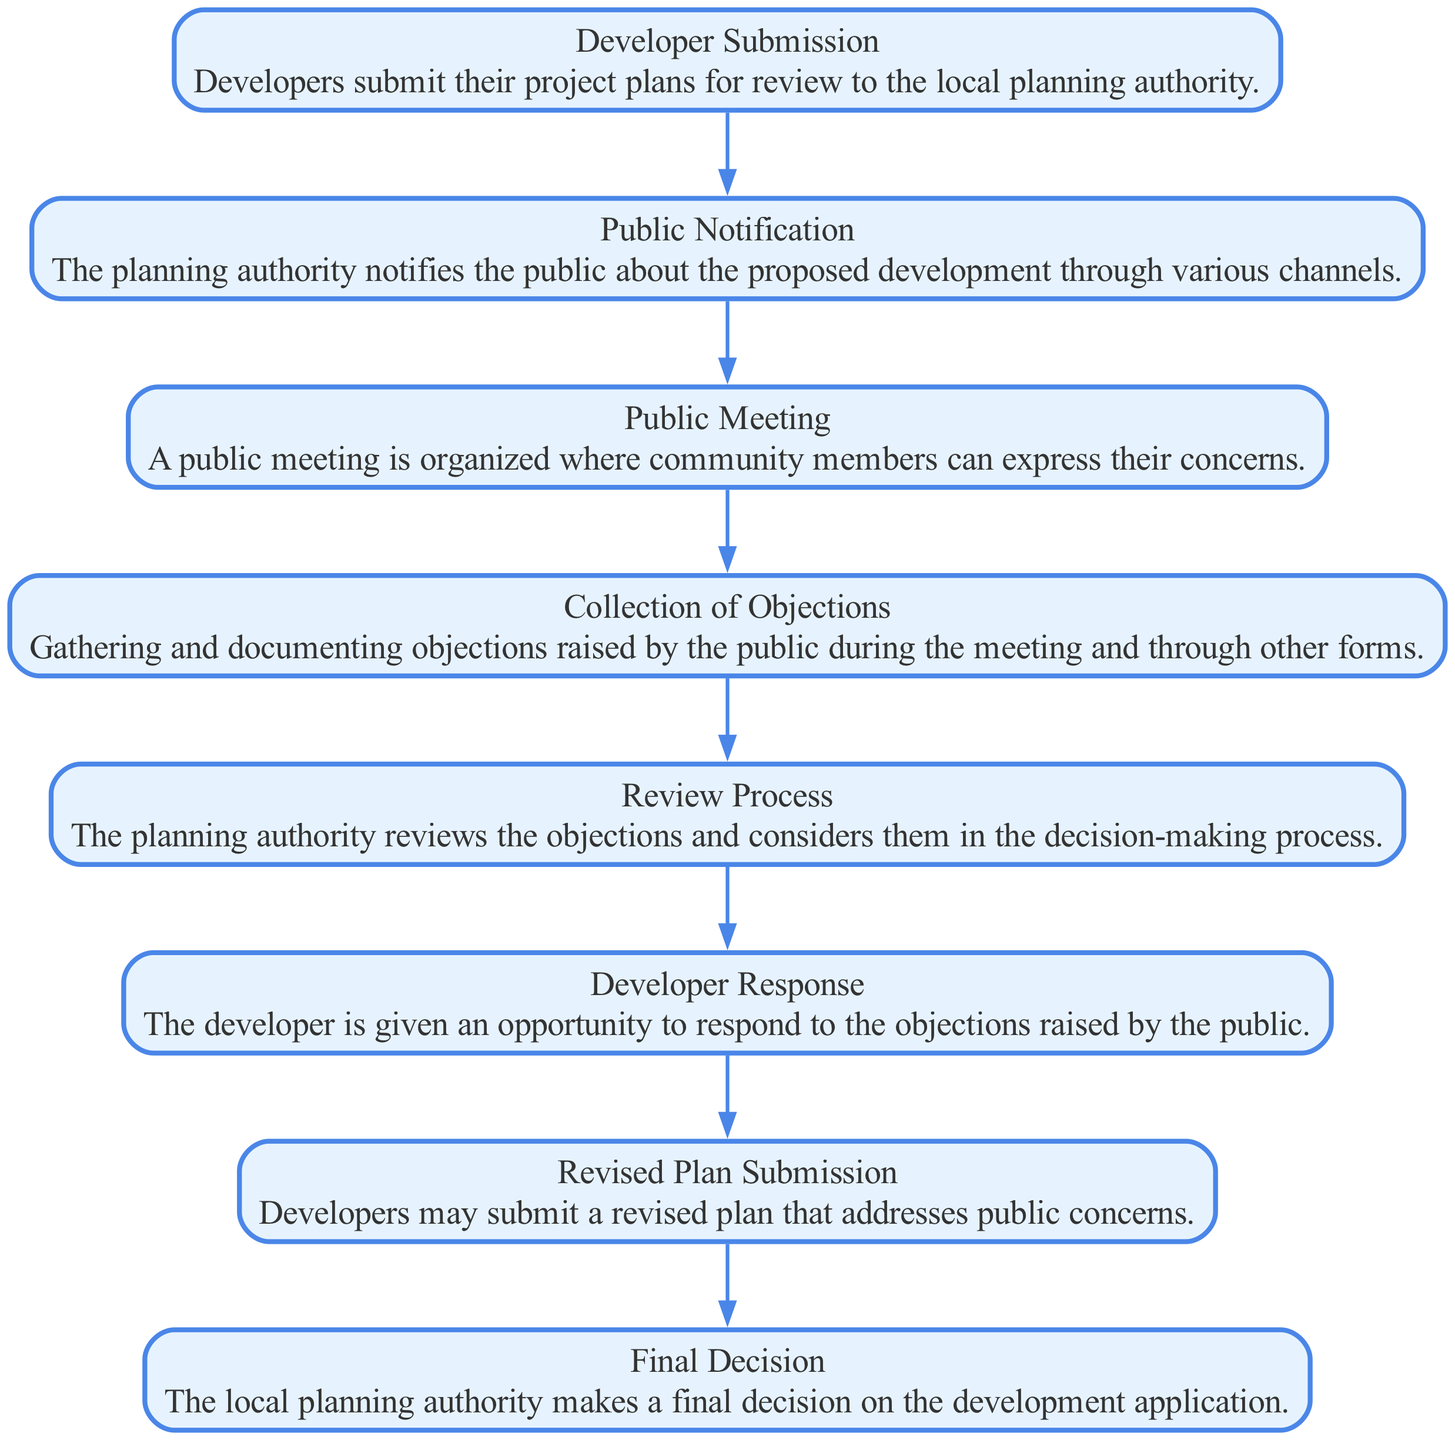What is the first step in the sequence? The first step in the sequence is "Developer Submission", where developers submit their project plans for review to the local planning authority.
Answer: Developer Submission How many total steps are there in the diagram? By counting the listed steps in the sequence, there are eight distinct steps from "Developer Submission" to "Final Decision."
Answer: Eight Which step follows "Public Meeting"? In the sequence, the step that follows "Public Meeting" is "Collection of Objections," where objections raised by the public are gathered and documented.
Answer: Collection of Objections What action does the developer take after the review process? After the Review Process, the action taken by the developer is to provide a "Developer Response" to address the objections raised by the public.
Answer: Developer Response What are the last two steps in the sequence? The last two steps in the sequence are "Revised Plan Submission" where developers may submit a revised plan, followed by "Final Decision" where the local planning authority makes the final decision.
Answer: Revised Plan Submission, Final Decision Which step includes public involvement? The "Public Meeting" step includes public involvement, allowing community members to express their concerns regarding the proposed development.
Answer: Public Meeting What is the purpose of the "Review Process"? The purpose of the "Review Process" is for the planning authority to review the objections raised and consider them in the decision-making process for the development.
Answer: Review Process Which step is directly after "Collection of Objections"? The step that comes directly after "Collection of Objections" is "Review Process," where the planning authority reviews the gathered objections.
Answer: Review Process What does the "Final Decision" signify in the sequence? The "Final Decision" signifies the conclusion of the entire sequence where the local planning authority makes a final decision on the development application, based on all previous steps.
Answer: Final Decision 